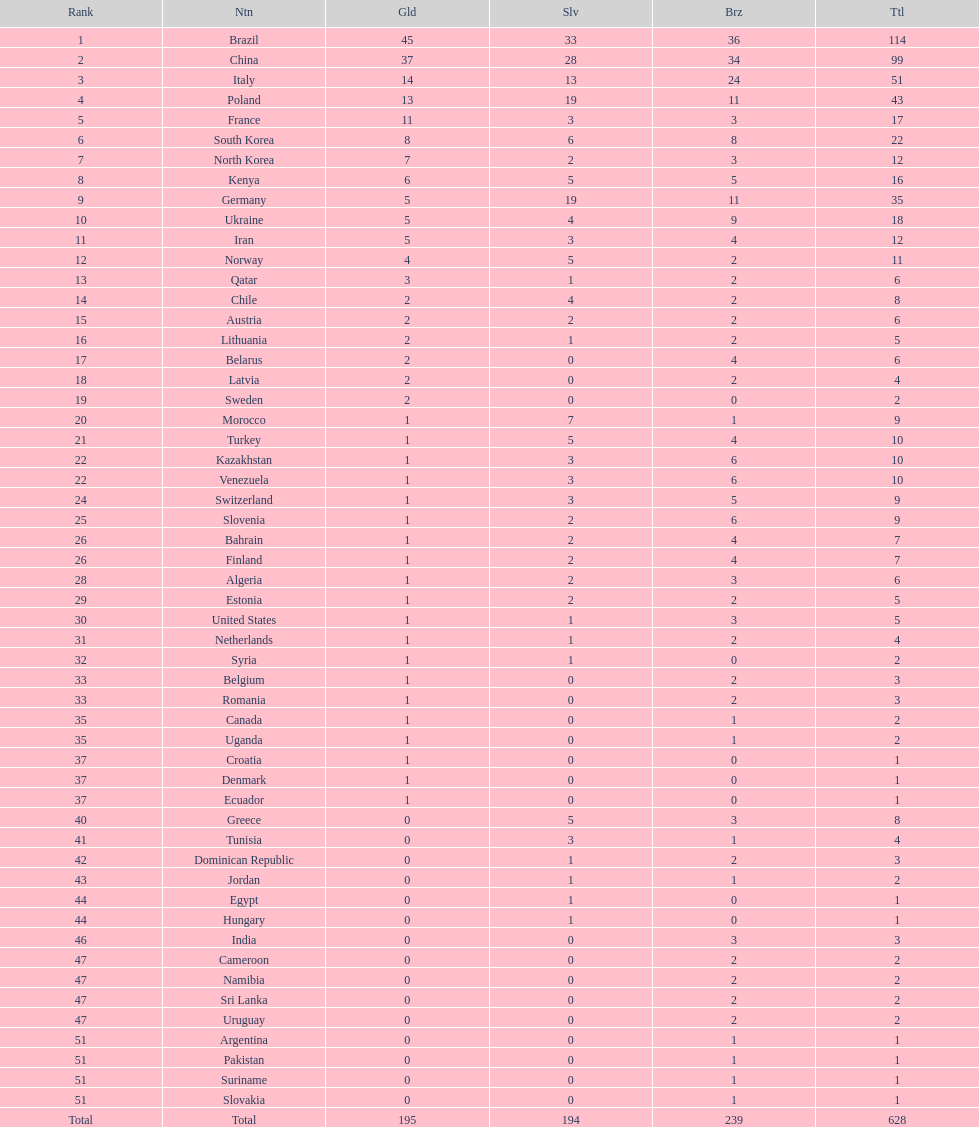Who only won 13 silver medals? Italy. 